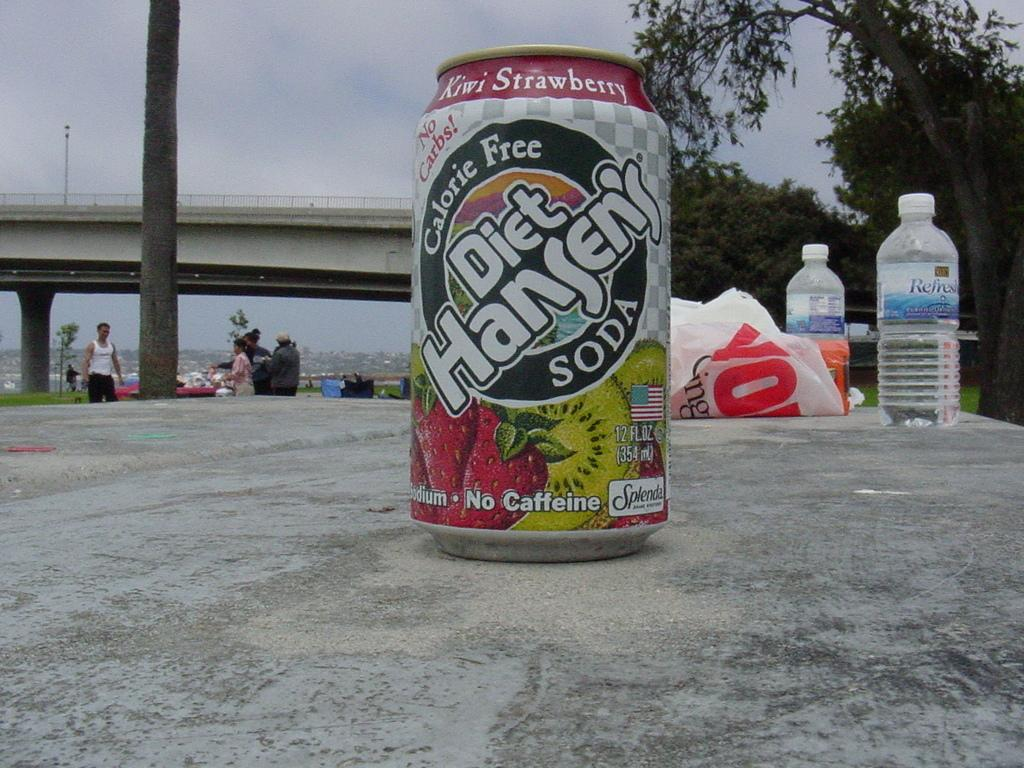<image>
Give a short and clear explanation of the subsequent image. A can of calorie free Diet Hansen's soda on a concrete table. 